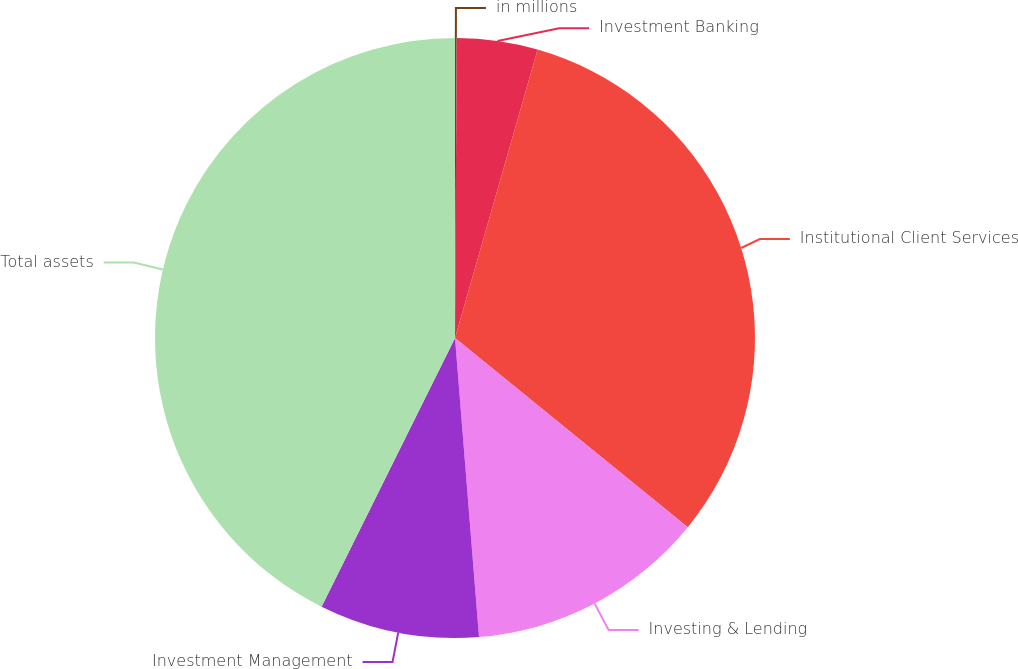Convert chart. <chart><loc_0><loc_0><loc_500><loc_500><pie_chart><fcel>in millions<fcel>Investment Banking<fcel>Institutional Client Services<fcel>Investing & Lending<fcel>Investment Management<fcel>Total assets<nl><fcel>0.09%<fcel>4.35%<fcel>31.42%<fcel>12.86%<fcel>8.61%<fcel>42.66%<nl></chart> 